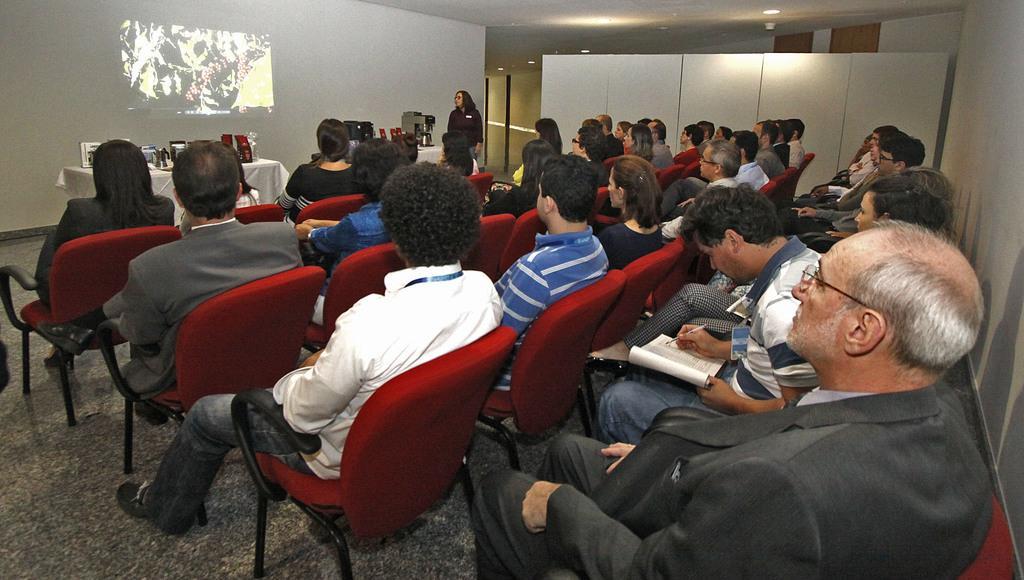Could you give a brief overview of what you see in this image? There is a group of people sitting on a chair and watching this screen. 